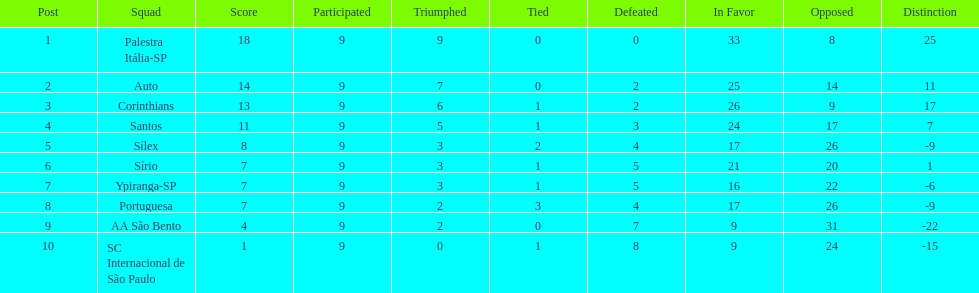Which team was the only team that was undefeated? Palestra Itália-SP. 